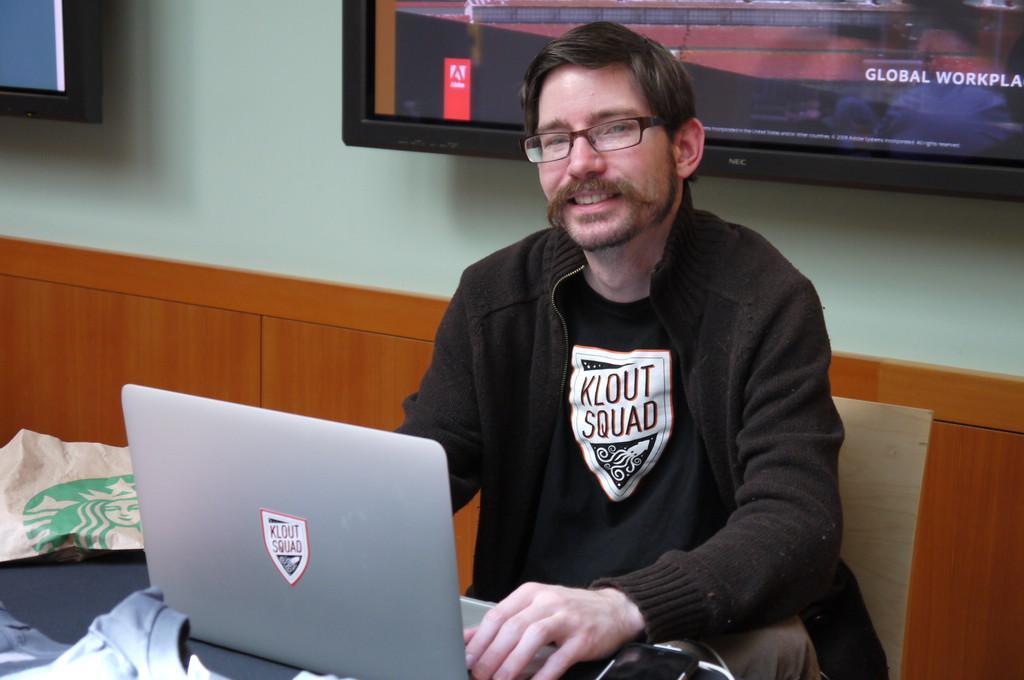Can you describe this image briefly? In this image we can see a man wearing the glasses and sitting on the chair in front of the table and on the table we can see the laptop, t shirt and a paper cover. In the background, we can see the televisions attached to the wall. We can also see the text on the television screen. 